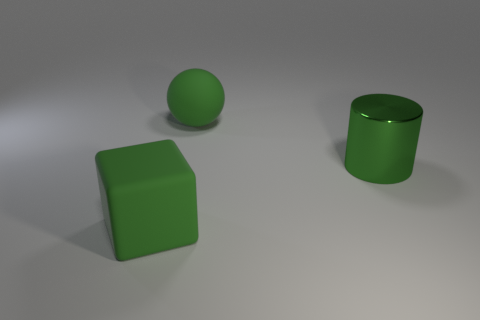Add 3 gray spheres. How many objects exist? 6 Subtract all cylinders. How many objects are left? 2 Add 1 small gray metallic cubes. How many small gray metallic cubes exist? 1 Subtract 0 brown cylinders. How many objects are left? 3 Subtract 1 spheres. How many spheres are left? 0 Subtract all big green matte cubes. Subtract all cylinders. How many objects are left? 1 Add 3 big matte cubes. How many big matte cubes are left? 4 